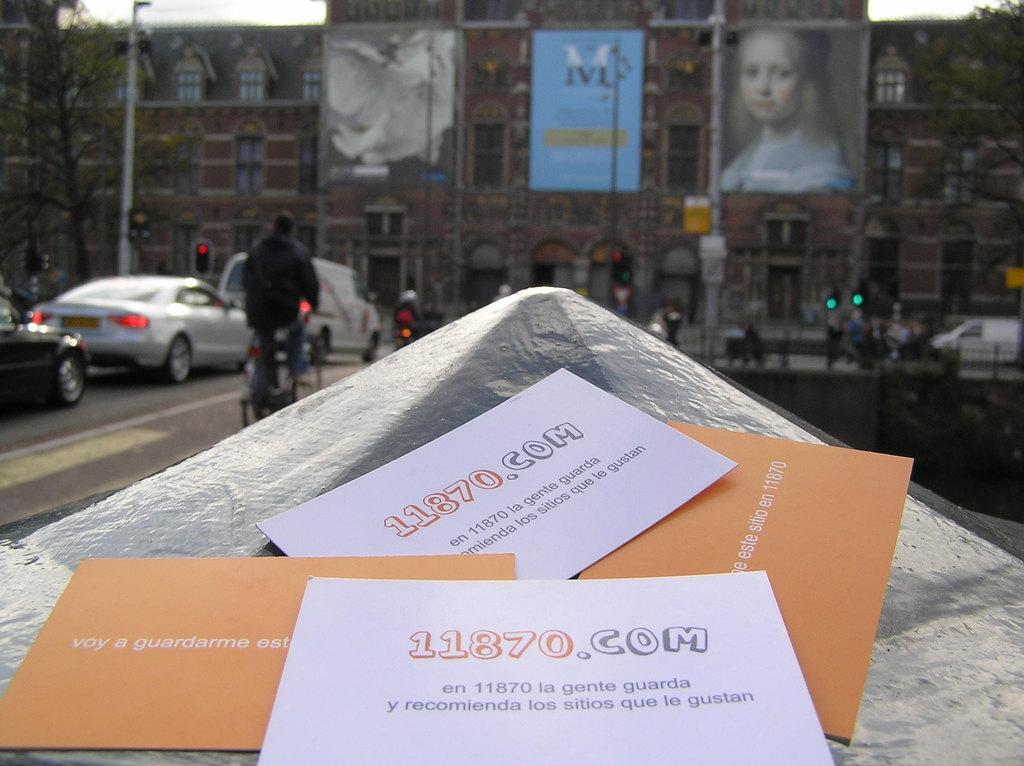Describe this image in one or two sentences. In this image I can see few cards in orange and white color, background I can see few vehicles, traffic signal, trees in green color, few buildings in brown color and sky is in white color. 